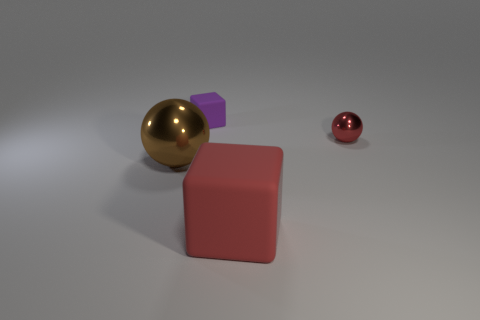What color is the tiny shiny sphere?
Your response must be concise. Red. There is a big thing on the right side of the brown metal ball; is its color the same as the small matte thing?
Give a very brief answer. No. There is another thing that is the same shape as the tiny red shiny object; what is its color?
Your response must be concise. Brown. What number of small objects are shiny balls or gray metallic blocks?
Give a very brief answer. 1. How big is the shiny object in front of the small red ball?
Offer a terse response. Large. Is there a sphere that has the same color as the large matte cube?
Offer a very short reply. Yes. Does the small sphere have the same color as the small rubber cube?
Keep it short and to the point. No. What shape is the object that is the same color as the tiny sphere?
Keep it short and to the point. Cube. There is a thing that is behind the red metallic ball; how many small matte cubes are on the right side of it?
Ensure brevity in your answer.  0. How many tiny spheres are made of the same material as the tiny purple cube?
Keep it short and to the point. 0. 